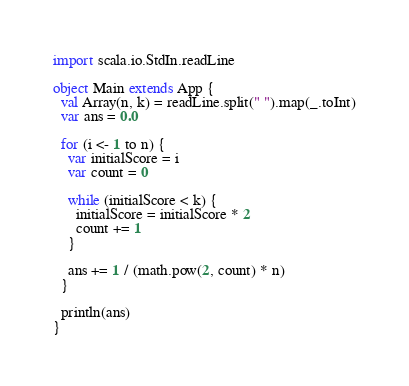Convert code to text. <code><loc_0><loc_0><loc_500><loc_500><_Scala_>import scala.io.StdIn.readLine

object Main extends App {
  val Array(n, k) = readLine.split(" ").map(_.toInt)
  var ans = 0.0

  for (i <- 1 to n) {
    var initialScore = i
    var count = 0

    while (initialScore < k) {
      initialScore = initialScore * 2
      count += 1
    }

    ans += 1 / (math.pow(2, count) * n)
  }

  println(ans)
}
</code> 